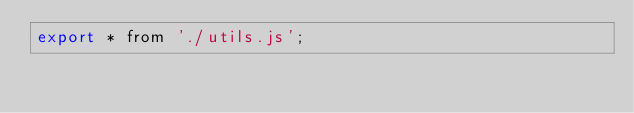Convert code to text. <code><loc_0><loc_0><loc_500><loc_500><_JavaScript_>export * from './utils.js';
</code> 